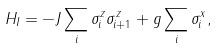<formula> <loc_0><loc_0><loc_500><loc_500>H _ { I } = - J \sum _ { i } \sigma _ { i } ^ { z } \sigma ^ { z } _ { i + 1 } + g \sum _ { i } \sigma _ { i } ^ { x } ,</formula> 